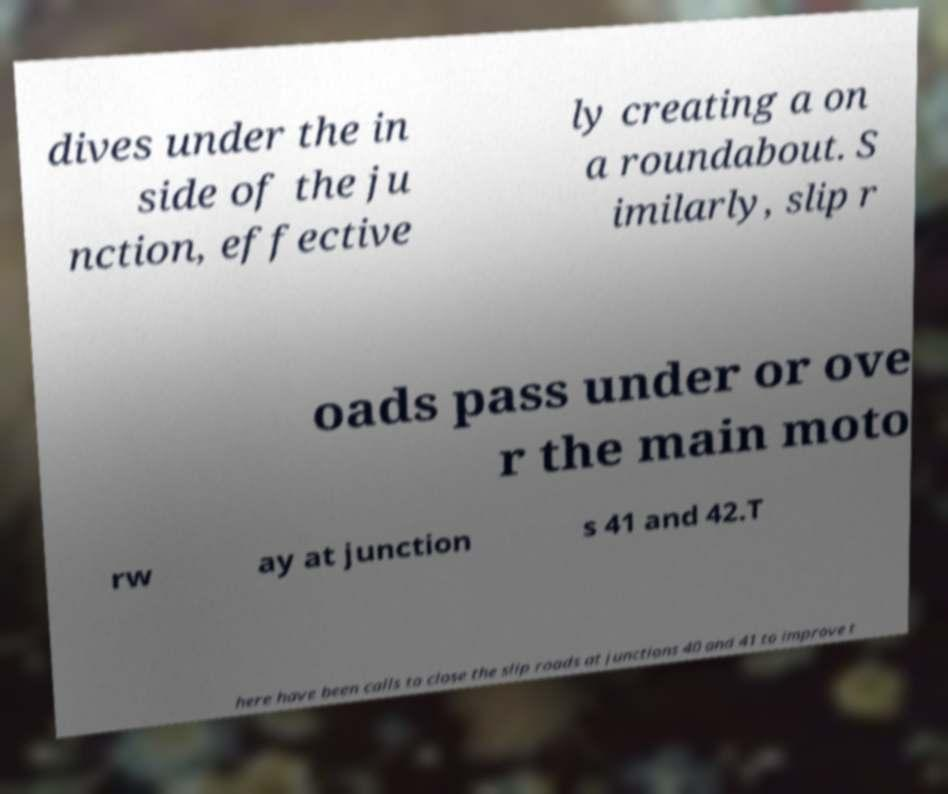For documentation purposes, I need the text within this image transcribed. Could you provide that? dives under the in side of the ju nction, effective ly creating a on a roundabout. S imilarly, slip r oads pass under or ove r the main moto rw ay at junction s 41 and 42.T here have been calls to close the slip roads at junctions 40 and 41 to improve t 